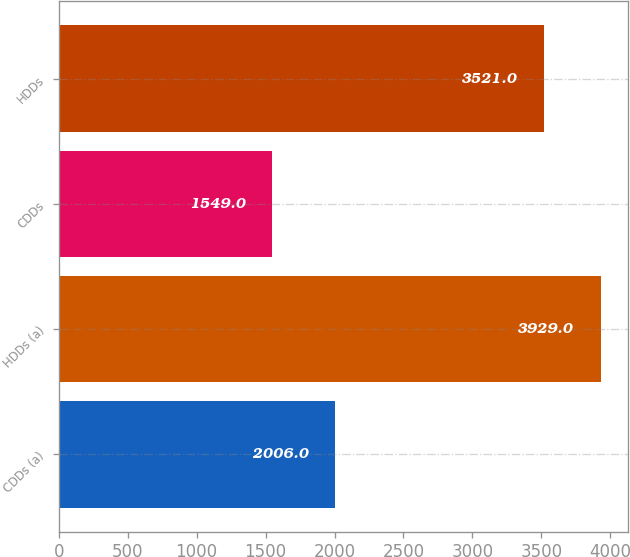Convert chart to OTSL. <chart><loc_0><loc_0><loc_500><loc_500><bar_chart><fcel>CDDs (a)<fcel>HDDs (a)<fcel>CDDs<fcel>HDDs<nl><fcel>2006<fcel>3929<fcel>1549<fcel>3521<nl></chart> 